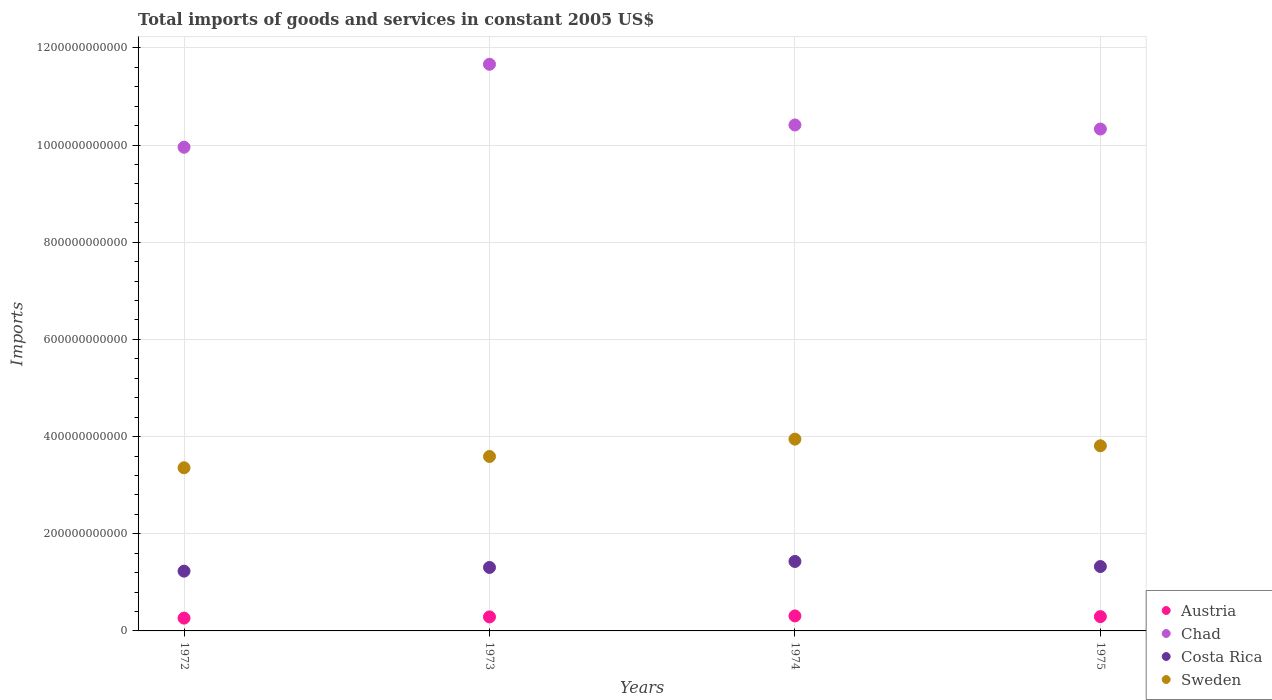What is the total imports of goods and services in Austria in 1974?
Provide a short and direct response. 3.09e+1. Across all years, what is the maximum total imports of goods and services in Austria?
Keep it short and to the point. 3.09e+1. Across all years, what is the minimum total imports of goods and services in Costa Rica?
Your answer should be very brief. 1.23e+11. What is the total total imports of goods and services in Austria in the graph?
Give a very brief answer. 1.15e+11. What is the difference between the total imports of goods and services in Chad in 1973 and that in 1974?
Your response must be concise. 1.25e+11. What is the difference between the total imports of goods and services in Austria in 1973 and the total imports of goods and services in Sweden in 1974?
Your response must be concise. -3.66e+11. What is the average total imports of goods and services in Sweden per year?
Your response must be concise. 3.68e+11. In the year 1973, what is the difference between the total imports of goods and services in Sweden and total imports of goods and services in Austria?
Provide a short and direct response. 3.30e+11. In how many years, is the total imports of goods and services in Sweden greater than 120000000000 US$?
Keep it short and to the point. 4. What is the ratio of the total imports of goods and services in Austria in 1972 to that in 1973?
Your response must be concise. 0.91. Is the difference between the total imports of goods and services in Sweden in 1972 and 1975 greater than the difference between the total imports of goods and services in Austria in 1972 and 1975?
Give a very brief answer. No. What is the difference between the highest and the second highest total imports of goods and services in Sweden?
Your answer should be very brief. 1.37e+1. What is the difference between the highest and the lowest total imports of goods and services in Chad?
Provide a short and direct response. 1.71e+11. In how many years, is the total imports of goods and services in Sweden greater than the average total imports of goods and services in Sweden taken over all years?
Offer a very short reply. 2. Is it the case that in every year, the sum of the total imports of goods and services in Sweden and total imports of goods and services in Costa Rica  is greater than the sum of total imports of goods and services in Austria and total imports of goods and services in Chad?
Offer a terse response. Yes. Is the total imports of goods and services in Costa Rica strictly less than the total imports of goods and services in Sweden over the years?
Give a very brief answer. Yes. How many years are there in the graph?
Offer a very short reply. 4. What is the difference between two consecutive major ticks on the Y-axis?
Your answer should be very brief. 2.00e+11. Are the values on the major ticks of Y-axis written in scientific E-notation?
Provide a short and direct response. No. Where does the legend appear in the graph?
Your answer should be compact. Bottom right. How many legend labels are there?
Keep it short and to the point. 4. How are the legend labels stacked?
Make the answer very short. Vertical. What is the title of the graph?
Ensure brevity in your answer.  Total imports of goods and services in constant 2005 US$. What is the label or title of the Y-axis?
Provide a succinct answer. Imports. What is the Imports in Austria in 1972?
Give a very brief answer. 2.63e+1. What is the Imports in Chad in 1972?
Make the answer very short. 9.95e+11. What is the Imports of Costa Rica in 1972?
Ensure brevity in your answer.  1.23e+11. What is the Imports of Sweden in 1972?
Your response must be concise. 3.36e+11. What is the Imports of Austria in 1973?
Offer a terse response. 2.89e+1. What is the Imports of Chad in 1973?
Offer a terse response. 1.17e+12. What is the Imports in Costa Rica in 1973?
Ensure brevity in your answer.  1.31e+11. What is the Imports of Sweden in 1973?
Offer a very short reply. 3.59e+11. What is the Imports in Austria in 1974?
Ensure brevity in your answer.  3.09e+1. What is the Imports of Chad in 1974?
Your answer should be compact. 1.04e+12. What is the Imports of Costa Rica in 1974?
Ensure brevity in your answer.  1.43e+11. What is the Imports of Sweden in 1974?
Ensure brevity in your answer.  3.95e+11. What is the Imports in Austria in 1975?
Your answer should be very brief. 2.94e+1. What is the Imports in Chad in 1975?
Provide a succinct answer. 1.03e+12. What is the Imports of Costa Rica in 1975?
Your response must be concise. 1.32e+11. What is the Imports in Sweden in 1975?
Give a very brief answer. 3.81e+11. Across all years, what is the maximum Imports of Austria?
Provide a succinct answer. 3.09e+1. Across all years, what is the maximum Imports of Chad?
Give a very brief answer. 1.17e+12. Across all years, what is the maximum Imports of Costa Rica?
Offer a terse response. 1.43e+11. Across all years, what is the maximum Imports of Sweden?
Your answer should be compact. 3.95e+11. Across all years, what is the minimum Imports in Austria?
Your response must be concise. 2.63e+1. Across all years, what is the minimum Imports in Chad?
Offer a terse response. 9.95e+11. Across all years, what is the minimum Imports of Costa Rica?
Provide a short and direct response. 1.23e+11. Across all years, what is the minimum Imports of Sweden?
Offer a terse response. 3.36e+11. What is the total Imports of Austria in the graph?
Provide a short and direct response. 1.15e+11. What is the total Imports of Chad in the graph?
Provide a short and direct response. 4.24e+12. What is the total Imports in Costa Rica in the graph?
Your answer should be very brief. 5.29e+11. What is the total Imports in Sweden in the graph?
Keep it short and to the point. 1.47e+12. What is the difference between the Imports in Austria in 1972 and that in 1973?
Your answer should be compact. -2.52e+09. What is the difference between the Imports in Chad in 1972 and that in 1973?
Your answer should be very brief. -1.71e+11. What is the difference between the Imports in Costa Rica in 1972 and that in 1973?
Give a very brief answer. -7.63e+09. What is the difference between the Imports of Sweden in 1972 and that in 1973?
Offer a very short reply. -2.33e+1. What is the difference between the Imports in Austria in 1972 and that in 1974?
Your response must be concise. -4.51e+09. What is the difference between the Imports of Chad in 1972 and that in 1974?
Provide a succinct answer. -4.58e+1. What is the difference between the Imports in Costa Rica in 1972 and that in 1974?
Offer a very short reply. -1.99e+1. What is the difference between the Imports in Sweden in 1972 and that in 1974?
Keep it short and to the point. -5.90e+1. What is the difference between the Imports in Austria in 1972 and that in 1975?
Make the answer very short. -3.08e+09. What is the difference between the Imports of Chad in 1972 and that in 1975?
Provide a succinct answer. -3.75e+1. What is the difference between the Imports in Costa Rica in 1972 and that in 1975?
Keep it short and to the point. -9.45e+09. What is the difference between the Imports in Sweden in 1972 and that in 1975?
Provide a succinct answer. -4.53e+1. What is the difference between the Imports of Austria in 1973 and that in 1974?
Your answer should be very brief. -1.99e+09. What is the difference between the Imports in Chad in 1973 and that in 1974?
Your answer should be very brief. 1.25e+11. What is the difference between the Imports in Costa Rica in 1973 and that in 1974?
Your answer should be very brief. -1.23e+1. What is the difference between the Imports of Sweden in 1973 and that in 1974?
Your response must be concise. -3.57e+1. What is the difference between the Imports of Austria in 1973 and that in 1975?
Keep it short and to the point. -5.59e+08. What is the difference between the Imports of Chad in 1973 and that in 1975?
Give a very brief answer. 1.33e+11. What is the difference between the Imports in Costa Rica in 1973 and that in 1975?
Your answer should be compact. -1.82e+09. What is the difference between the Imports in Sweden in 1973 and that in 1975?
Your answer should be very brief. -2.20e+1. What is the difference between the Imports of Austria in 1974 and that in 1975?
Make the answer very short. 1.43e+09. What is the difference between the Imports of Chad in 1974 and that in 1975?
Your answer should be compact. 8.34e+09. What is the difference between the Imports of Costa Rica in 1974 and that in 1975?
Your response must be concise. 1.05e+1. What is the difference between the Imports of Sweden in 1974 and that in 1975?
Offer a very short reply. 1.37e+1. What is the difference between the Imports in Austria in 1972 and the Imports in Chad in 1973?
Keep it short and to the point. -1.14e+12. What is the difference between the Imports in Austria in 1972 and the Imports in Costa Rica in 1973?
Keep it short and to the point. -1.04e+11. What is the difference between the Imports in Austria in 1972 and the Imports in Sweden in 1973?
Keep it short and to the point. -3.33e+11. What is the difference between the Imports in Chad in 1972 and the Imports in Costa Rica in 1973?
Your answer should be very brief. 8.65e+11. What is the difference between the Imports in Chad in 1972 and the Imports in Sweden in 1973?
Keep it short and to the point. 6.36e+11. What is the difference between the Imports in Costa Rica in 1972 and the Imports in Sweden in 1973?
Offer a terse response. -2.36e+11. What is the difference between the Imports of Austria in 1972 and the Imports of Chad in 1974?
Offer a terse response. -1.01e+12. What is the difference between the Imports in Austria in 1972 and the Imports in Costa Rica in 1974?
Give a very brief answer. -1.17e+11. What is the difference between the Imports of Austria in 1972 and the Imports of Sweden in 1974?
Offer a very short reply. -3.68e+11. What is the difference between the Imports in Chad in 1972 and the Imports in Costa Rica in 1974?
Your answer should be compact. 8.53e+11. What is the difference between the Imports of Chad in 1972 and the Imports of Sweden in 1974?
Offer a terse response. 6.01e+11. What is the difference between the Imports in Costa Rica in 1972 and the Imports in Sweden in 1974?
Provide a short and direct response. -2.72e+11. What is the difference between the Imports in Austria in 1972 and the Imports in Chad in 1975?
Provide a succinct answer. -1.01e+12. What is the difference between the Imports of Austria in 1972 and the Imports of Costa Rica in 1975?
Your answer should be compact. -1.06e+11. What is the difference between the Imports of Austria in 1972 and the Imports of Sweden in 1975?
Your answer should be compact. -3.55e+11. What is the difference between the Imports of Chad in 1972 and the Imports of Costa Rica in 1975?
Your answer should be compact. 8.63e+11. What is the difference between the Imports of Chad in 1972 and the Imports of Sweden in 1975?
Ensure brevity in your answer.  6.14e+11. What is the difference between the Imports in Costa Rica in 1972 and the Imports in Sweden in 1975?
Your response must be concise. -2.58e+11. What is the difference between the Imports of Austria in 1973 and the Imports of Chad in 1974?
Provide a succinct answer. -1.01e+12. What is the difference between the Imports of Austria in 1973 and the Imports of Costa Rica in 1974?
Offer a very short reply. -1.14e+11. What is the difference between the Imports in Austria in 1973 and the Imports in Sweden in 1974?
Offer a terse response. -3.66e+11. What is the difference between the Imports of Chad in 1973 and the Imports of Costa Rica in 1974?
Make the answer very short. 1.02e+12. What is the difference between the Imports of Chad in 1973 and the Imports of Sweden in 1974?
Offer a very short reply. 7.72e+11. What is the difference between the Imports in Costa Rica in 1973 and the Imports in Sweden in 1974?
Make the answer very short. -2.64e+11. What is the difference between the Imports of Austria in 1973 and the Imports of Chad in 1975?
Your answer should be compact. -1.00e+12. What is the difference between the Imports in Austria in 1973 and the Imports in Costa Rica in 1975?
Your response must be concise. -1.04e+11. What is the difference between the Imports in Austria in 1973 and the Imports in Sweden in 1975?
Offer a terse response. -3.52e+11. What is the difference between the Imports of Chad in 1973 and the Imports of Costa Rica in 1975?
Your response must be concise. 1.03e+12. What is the difference between the Imports in Chad in 1973 and the Imports in Sweden in 1975?
Give a very brief answer. 7.85e+11. What is the difference between the Imports in Costa Rica in 1973 and the Imports in Sweden in 1975?
Offer a terse response. -2.50e+11. What is the difference between the Imports in Austria in 1974 and the Imports in Chad in 1975?
Offer a terse response. -1.00e+12. What is the difference between the Imports of Austria in 1974 and the Imports of Costa Rica in 1975?
Provide a succinct answer. -1.02e+11. What is the difference between the Imports in Austria in 1974 and the Imports in Sweden in 1975?
Keep it short and to the point. -3.50e+11. What is the difference between the Imports of Chad in 1974 and the Imports of Costa Rica in 1975?
Ensure brevity in your answer.  9.09e+11. What is the difference between the Imports in Chad in 1974 and the Imports in Sweden in 1975?
Your answer should be very brief. 6.60e+11. What is the difference between the Imports of Costa Rica in 1974 and the Imports of Sweden in 1975?
Offer a terse response. -2.38e+11. What is the average Imports of Austria per year?
Provide a succinct answer. 2.89e+1. What is the average Imports in Chad per year?
Your answer should be very brief. 1.06e+12. What is the average Imports of Costa Rica per year?
Offer a terse response. 1.32e+11. What is the average Imports in Sweden per year?
Make the answer very short. 3.68e+11. In the year 1972, what is the difference between the Imports of Austria and Imports of Chad?
Provide a short and direct response. -9.69e+11. In the year 1972, what is the difference between the Imports of Austria and Imports of Costa Rica?
Your answer should be compact. -9.67e+1. In the year 1972, what is the difference between the Imports of Austria and Imports of Sweden?
Offer a very short reply. -3.09e+11. In the year 1972, what is the difference between the Imports of Chad and Imports of Costa Rica?
Provide a short and direct response. 8.72e+11. In the year 1972, what is the difference between the Imports in Chad and Imports in Sweden?
Provide a short and direct response. 6.60e+11. In the year 1972, what is the difference between the Imports in Costa Rica and Imports in Sweden?
Your answer should be very brief. -2.13e+11. In the year 1973, what is the difference between the Imports of Austria and Imports of Chad?
Provide a short and direct response. -1.14e+12. In the year 1973, what is the difference between the Imports in Austria and Imports in Costa Rica?
Offer a very short reply. -1.02e+11. In the year 1973, what is the difference between the Imports in Austria and Imports in Sweden?
Offer a terse response. -3.30e+11. In the year 1973, what is the difference between the Imports in Chad and Imports in Costa Rica?
Your answer should be very brief. 1.04e+12. In the year 1973, what is the difference between the Imports in Chad and Imports in Sweden?
Provide a succinct answer. 8.07e+11. In the year 1973, what is the difference between the Imports in Costa Rica and Imports in Sweden?
Provide a succinct answer. -2.28e+11. In the year 1974, what is the difference between the Imports in Austria and Imports in Chad?
Your answer should be very brief. -1.01e+12. In the year 1974, what is the difference between the Imports of Austria and Imports of Costa Rica?
Keep it short and to the point. -1.12e+11. In the year 1974, what is the difference between the Imports in Austria and Imports in Sweden?
Your response must be concise. -3.64e+11. In the year 1974, what is the difference between the Imports in Chad and Imports in Costa Rica?
Make the answer very short. 8.98e+11. In the year 1974, what is the difference between the Imports in Chad and Imports in Sweden?
Keep it short and to the point. 6.47e+11. In the year 1974, what is the difference between the Imports of Costa Rica and Imports of Sweden?
Offer a terse response. -2.52e+11. In the year 1975, what is the difference between the Imports in Austria and Imports in Chad?
Offer a terse response. -1.00e+12. In the year 1975, what is the difference between the Imports in Austria and Imports in Costa Rica?
Your answer should be compact. -1.03e+11. In the year 1975, what is the difference between the Imports in Austria and Imports in Sweden?
Give a very brief answer. -3.52e+11. In the year 1975, what is the difference between the Imports of Chad and Imports of Costa Rica?
Ensure brevity in your answer.  9.00e+11. In the year 1975, what is the difference between the Imports in Chad and Imports in Sweden?
Your response must be concise. 6.52e+11. In the year 1975, what is the difference between the Imports in Costa Rica and Imports in Sweden?
Your response must be concise. -2.49e+11. What is the ratio of the Imports in Austria in 1972 to that in 1973?
Provide a short and direct response. 0.91. What is the ratio of the Imports in Chad in 1972 to that in 1973?
Offer a terse response. 0.85. What is the ratio of the Imports of Costa Rica in 1972 to that in 1973?
Offer a very short reply. 0.94. What is the ratio of the Imports of Sweden in 1972 to that in 1973?
Your answer should be very brief. 0.94. What is the ratio of the Imports in Austria in 1972 to that in 1974?
Your response must be concise. 0.85. What is the ratio of the Imports of Chad in 1972 to that in 1974?
Your answer should be very brief. 0.96. What is the ratio of the Imports in Costa Rica in 1972 to that in 1974?
Give a very brief answer. 0.86. What is the ratio of the Imports of Sweden in 1972 to that in 1974?
Provide a succinct answer. 0.85. What is the ratio of the Imports in Austria in 1972 to that in 1975?
Make the answer very short. 0.9. What is the ratio of the Imports of Chad in 1972 to that in 1975?
Keep it short and to the point. 0.96. What is the ratio of the Imports of Costa Rica in 1972 to that in 1975?
Keep it short and to the point. 0.93. What is the ratio of the Imports in Sweden in 1972 to that in 1975?
Provide a short and direct response. 0.88. What is the ratio of the Imports of Austria in 1973 to that in 1974?
Offer a very short reply. 0.94. What is the ratio of the Imports of Chad in 1973 to that in 1974?
Your answer should be very brief. 1.12. What is the ratio of the Imports in Costa Rica in 1973 to that in 1974?
Make the answer very short. 0.91. What is the ratio of the Imports of Sweden in 1973 to that in 1974?
Your answer should be compact. 0.91. What is the ratio of the Imports of Chad in 1973 to that in 1975?
Provide a short and direct response. 1.13. What is the ratio of the Imports in Costa Rica in 1973 to that in 1975?
Provide a succinct answer. 0.99. What is the ratio of the Imports of Sweden in 1973 to that in 1975?
Your answer should be very brief. 0.94. What is the ratio of the Imports of Austria in 1974 to that in 1975?
Keep it short and to the point. 1.05. What is the ratio of the Imports in Chad in 1974 to that in 1975?
Keep it short and to the point. 1.01. What is the ratio of the Imports in Costa Rica in 1974 to that in 1975?
Your response must be concise. 1.08. What is the ratio of the Imports of Sweden in 1974 to that in 1975?
Offer a terse response. 1.04. What is the difference between the highest and the second highest Imports in Austria?
Offer a terse response. 1.43e+09. What is the difference between the highest and the second highest Imports of Chad?
Your answer should be compact. 1.25e+11. What is the difference between the highest and the second highest Imports of Costa Rica?
Offer a very short reply. 1.05e+1. What is the difference between the highest and the second highest Imports of Sweden?
Keep it short and to the point. 1.37e+1. What is the difference between the highest and the lowest Imports in Austria?
Provide a succinct answer. 4.51e+09. What is the difference between the highest and the lowest Imports in Chad?
Keep it short and to the point. 1.71e+11. What is the difference between the highest and the lowest Imports in Costa Rica?
Ensure brevity in your answer.  1.99e+1. What is the difference between the highest and the lowest Imports of Sweden?
Keep it short and to the point. 5.90e+1. 